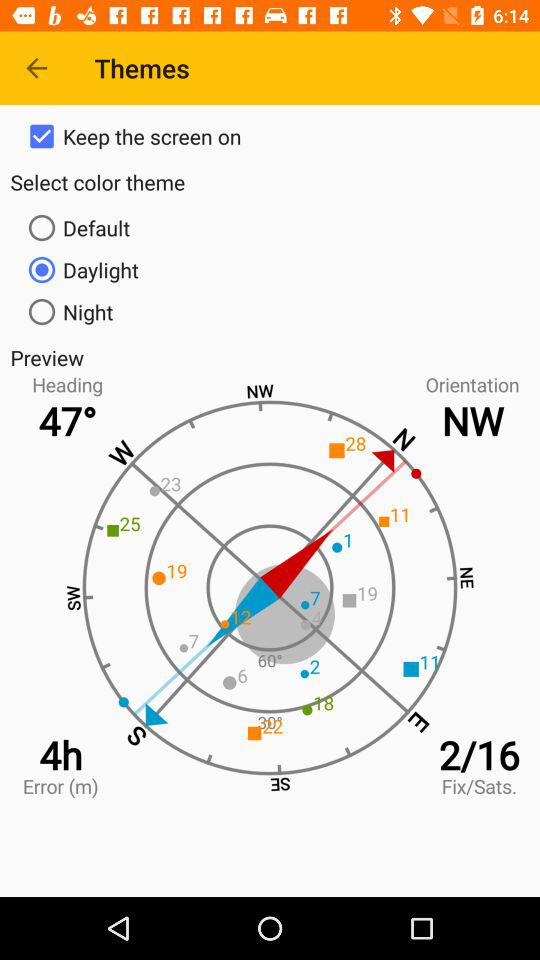What is the "Heading"? The "Heading" is 47°. 